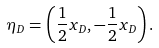Convert formula to latex. <formula><loc_0><loc_0><loc_500><loc_500>\eta _ { D } = \left ( \frac { 1 } { 2 } x _ { D } , - \frac { 1 } { 2 } x _ { D } \right ) .</formula> 